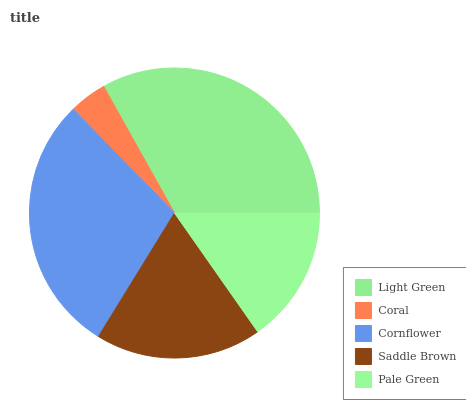Is Coral the minimum?
Answer yes or no. Yes. Is Light Green the maximum?
Answer yes or no. Yes. Is Cornflower the minimum?
Answer yes or no. No. Is Cornflower the maximum?
Answer yes or no. No. Is Cornflower greater than Coral?
Answer yes or no. Yes. Is Coral less than Cornflower?
Answer yes or no. Yes. Is Coral greater than Cornflower?
Answer yes or no. No. Is Cornflower less than Coral?
Answer yes or no. No. Is Saddle Brown the high median?
Answer yes or no. Yes. Is Saddle Brown the low median?
Answer yes or no. Yes. Is Pale Green the high median?
Answer yes or no. No. Is Coral the low median?
Answer yes or no. No. 